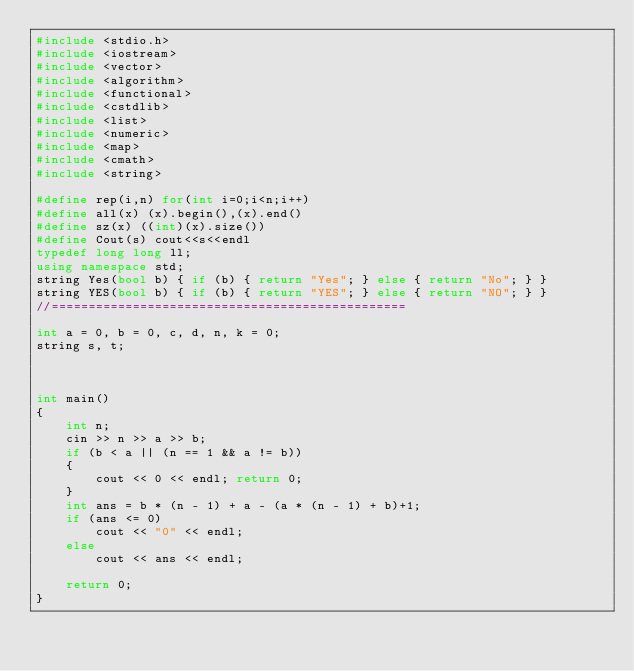<code> <loc_0><loc_0><loc_500><loc_500><_C++_>#include <stdio.h>
#include <iostream>
#include <vector>
#include <algorithm>
#include <functional>
#include <cstdlib>
#include <list>
#include <numeric>
#include <map>
#include <cmath>
#include <string>

#define rep(i,n) for(int i=0;i<n;i++)
#define all(x) (x).begin(),(x).end()
#define sz(x) ((int)(x).size())
#define Cout(s) cout<<s<<endl
typedef long long ll;
using namespace std;
string Yes(bool b) { if (b) { return "Yes"; } else { return "No"; } }
string YES(bool b) { if (b) { return "YES"; } else { return "NO"; } }
//================================================

int a = 0, b = 0, c, d, n, k = 0;
string s, t;



int main()
{
	int n; 
	cin >> n >> a >> b;
	if (b < a || (n == 1 && a != b))
	{
		cout << 0 << endl; return 0;
	}
	int ans = b * (n - 1) + a - (a * (n - 1) + b)+1;
	if (ans <= 0)
		cout << "0" << endl;
	else
		cout << ans << endl;

	return 0;
}</code> 